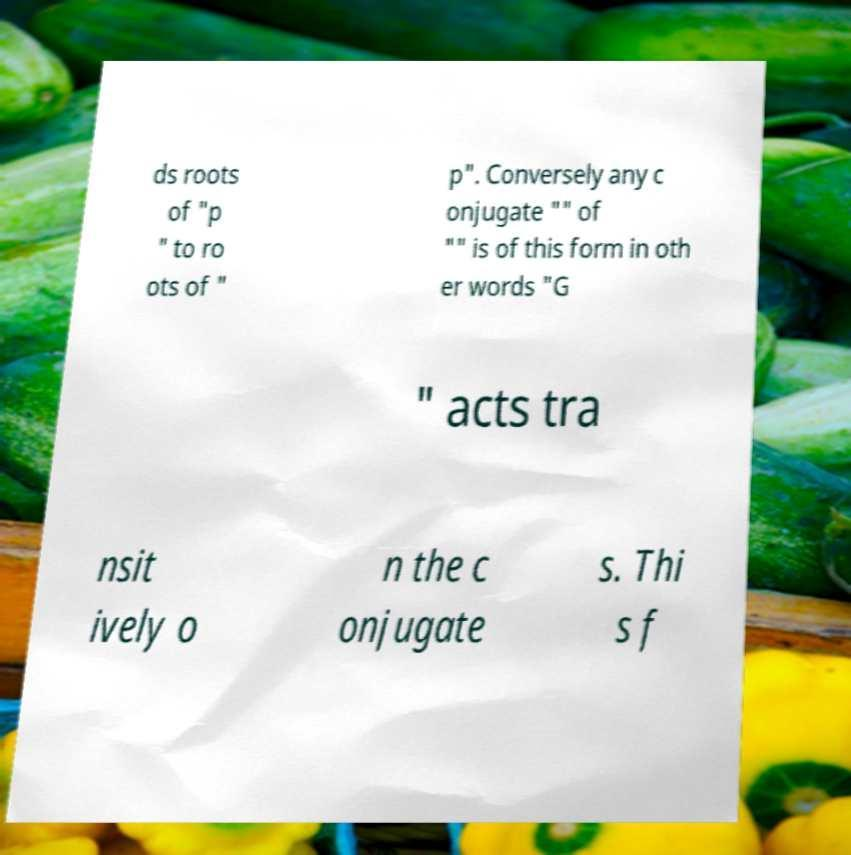I need the written content from this picture converted into text. Can you do that? ds roots of "p " to ro ots of " p". Conversely any c onjugate "" of "" is of this form in oth er words "G " acts tra nsit ively o n the c onjugate s. Thi s f 